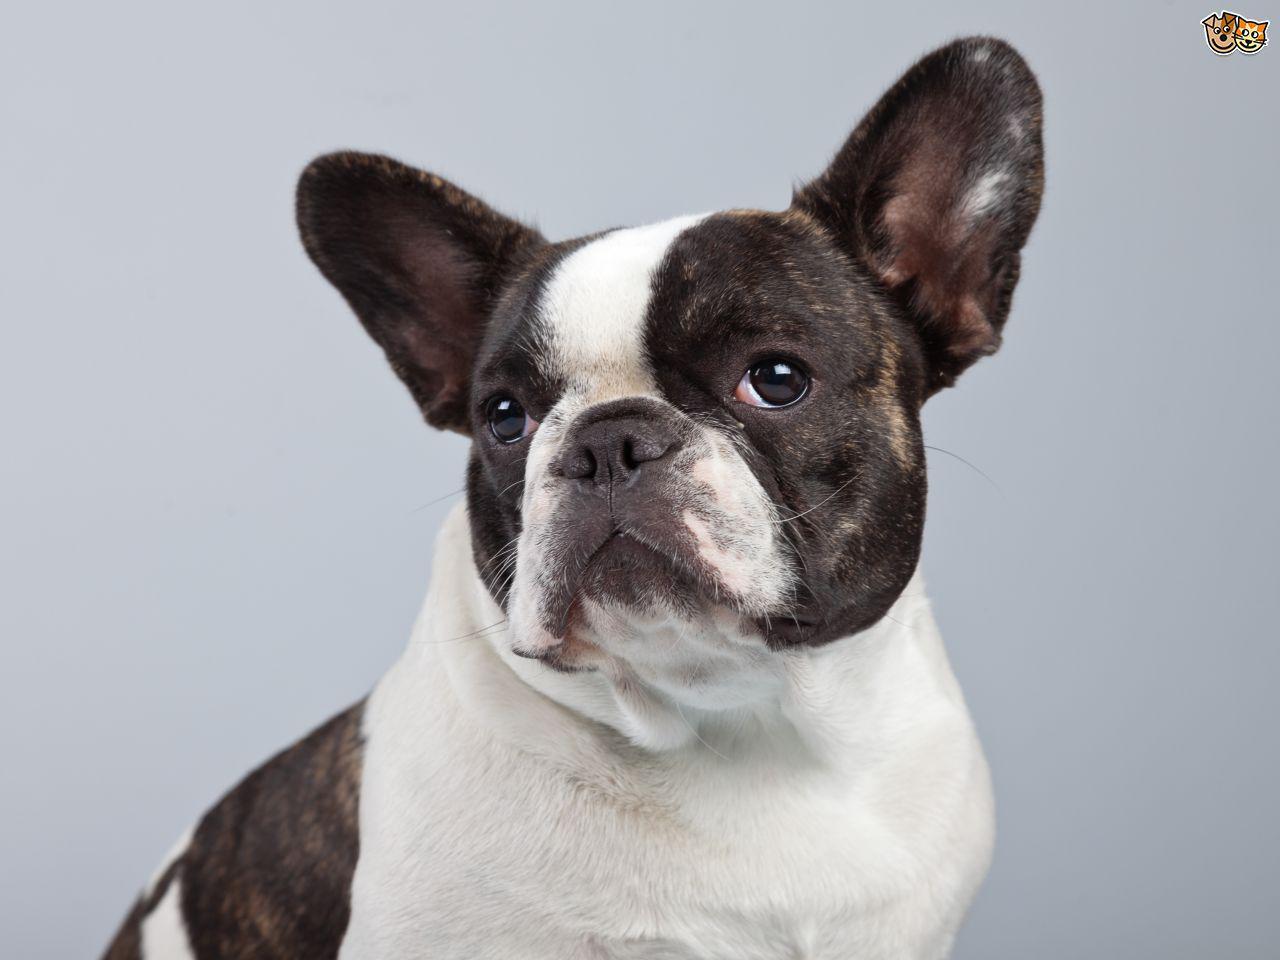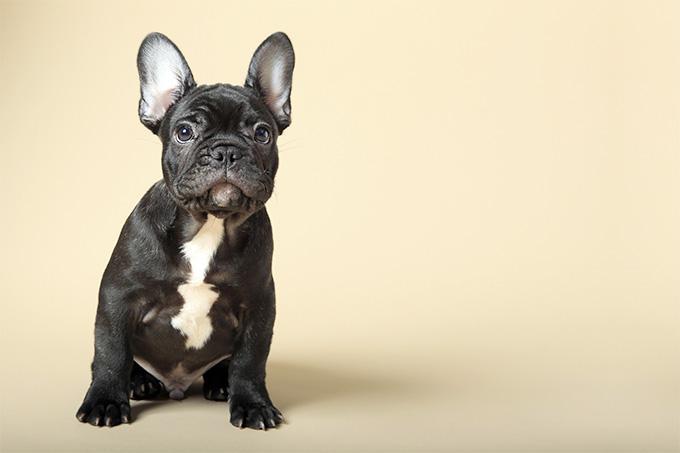The first image is the image on the left, the second image is the image on the right. Considering the images on both sides, is "There are two french bulldogs, and zero english bulldogs." valid? Answer yes or no. Yes. The first image is the image on the left, the second image is the image on the right. Assess this claim about the two images: "There is at least one dog standing on grass-covered ground.". Correct or not? Answer yes or no. No. 